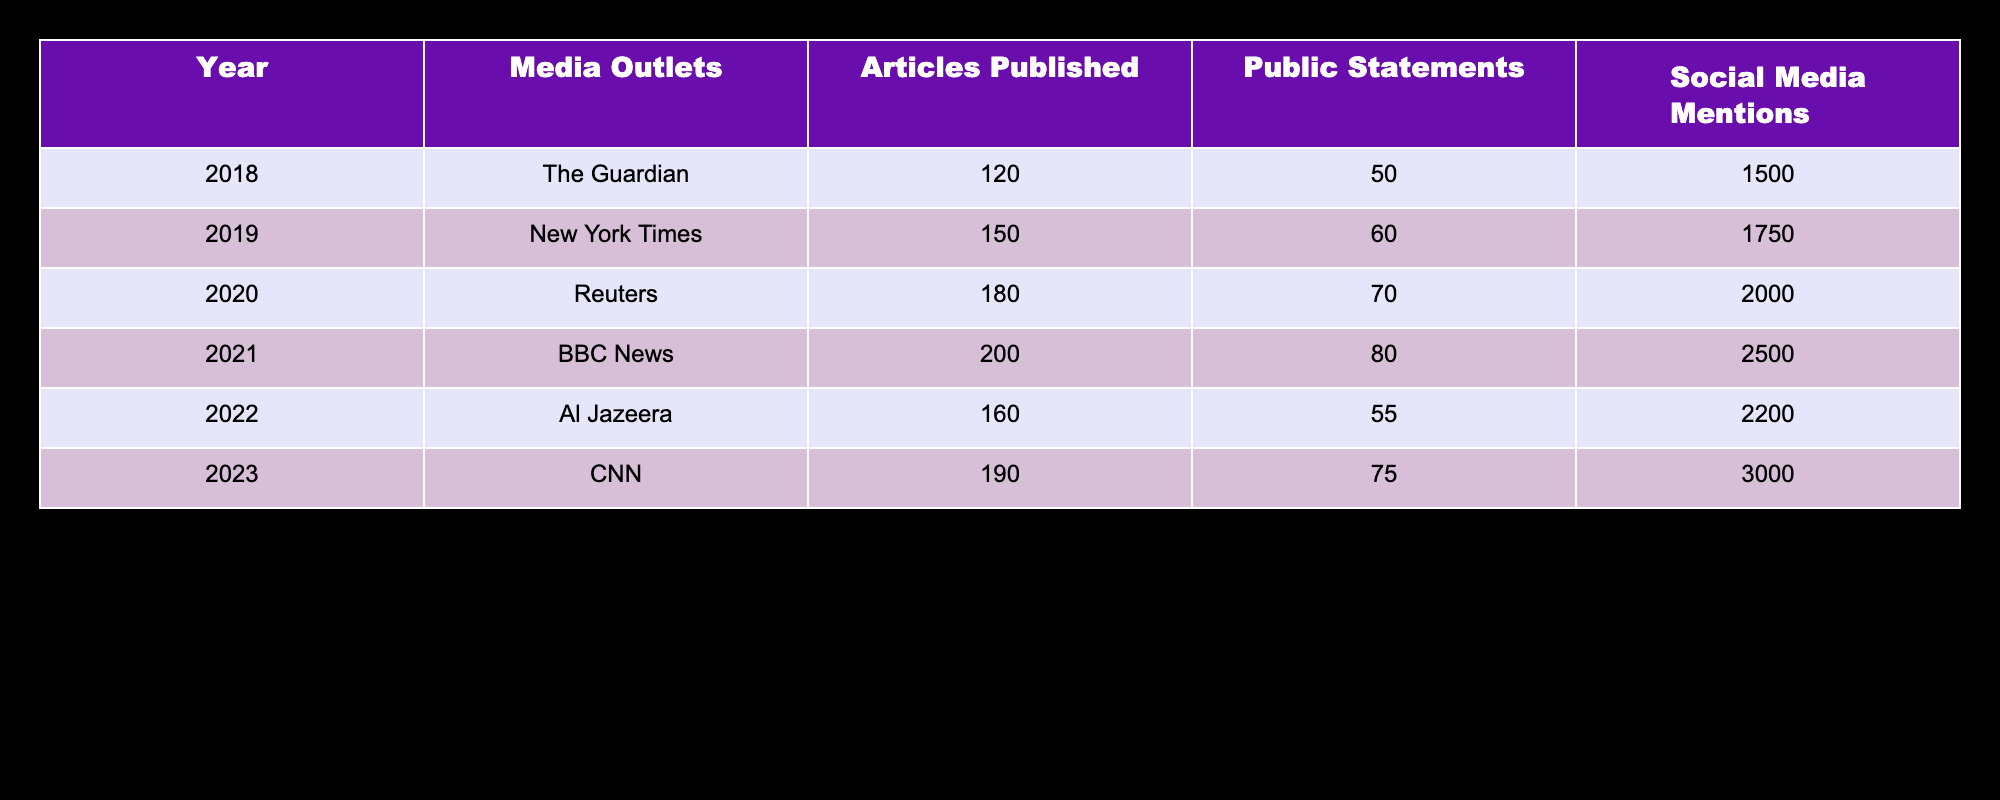What media outlet published the most articles on climate change in 2020? According to the table, Reuters published 180 articles in 2020, which is the highest number among the listed media outlets for that year.
Answer: Reuters Which year saw the highest number of public statements by media outlets? Looking at the column for public statements, 2021 had the highest count with 80 statements made by BBC News.
Answer: 2021 How many total articles were published across all years listed in the table? To find the total, we add up the articles published each year: 120 (2018) + 150 (2019) + 180 (2020) + 200 (2021) + 160 (2022) + 190 (2023) = 1100 articles.
Answer: 1100 Did Al Jazeera have more social media mentions than The Guardian in 2022? In 2022, Al Jazeera had 2200 social media mentions, while The Guardian's social media mentions are not listed for that year. However, the table indicates higher mentions for Al Jazeera, implying yes.
Answer: Yes What was the average number of articles published per year over the given period? The average is calculated by taking the total articles published (1100) and dividing by the number of years (6), which results in 1100/6 ≈ 183.33 articles per year.
Answer: 183.33 Which media outlet had the least number of public statements over the years presented? Upon reviewing the public statements column, Al Jazeera made the lowest number of public statements, with only 55 in 2022.
Answer: Al Jazeera Which year experienced the greatest increase in social media mentions compared to the previous year? By examining the social media mentions year-by-year: the increase from 2022 (2200) to 2023 (3000) is 800. This is greater than any other year’s increase, confirming it as the highest.
Answer: 2022 to 2023 Is it true that CNN had more articles published than New York Times in 2019? The table shows CNN published 190 articles in 2023, whereas the New York Times published 150 articles in 2019. This comparison indicates it is not true.
Answer: No 